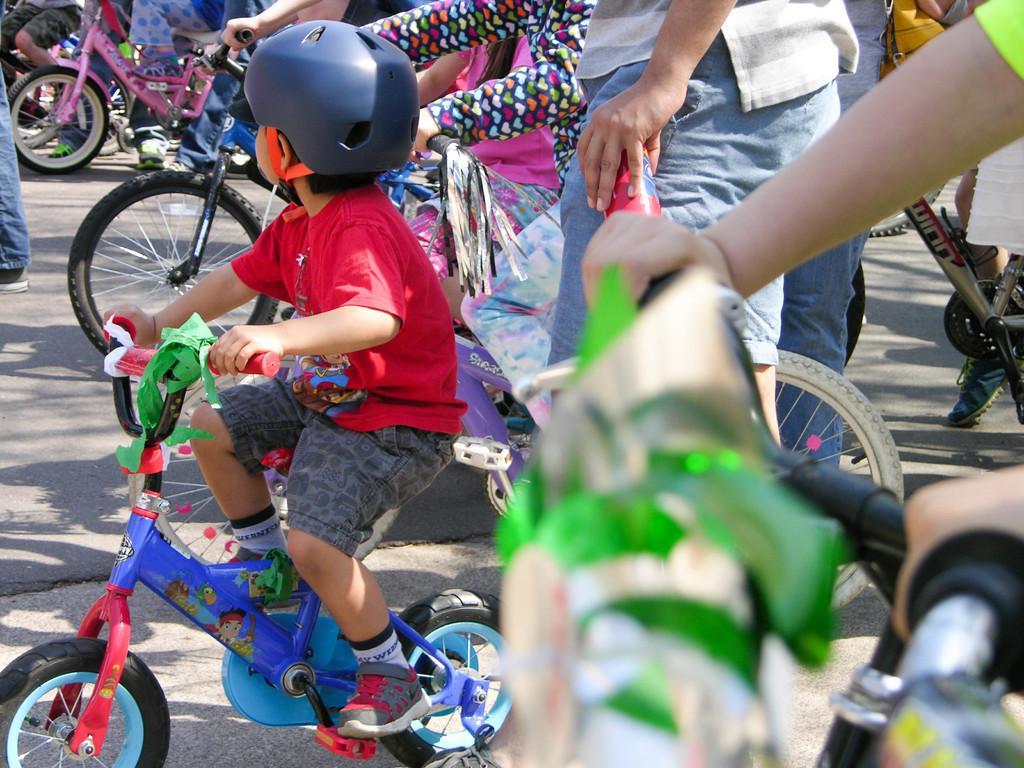How would you summarize this image in a sentence or two? In this image i can see a kid riding bicycle on a road, at the back ground i can see few other persons some are standing and a some are riding bicycle on the road. 